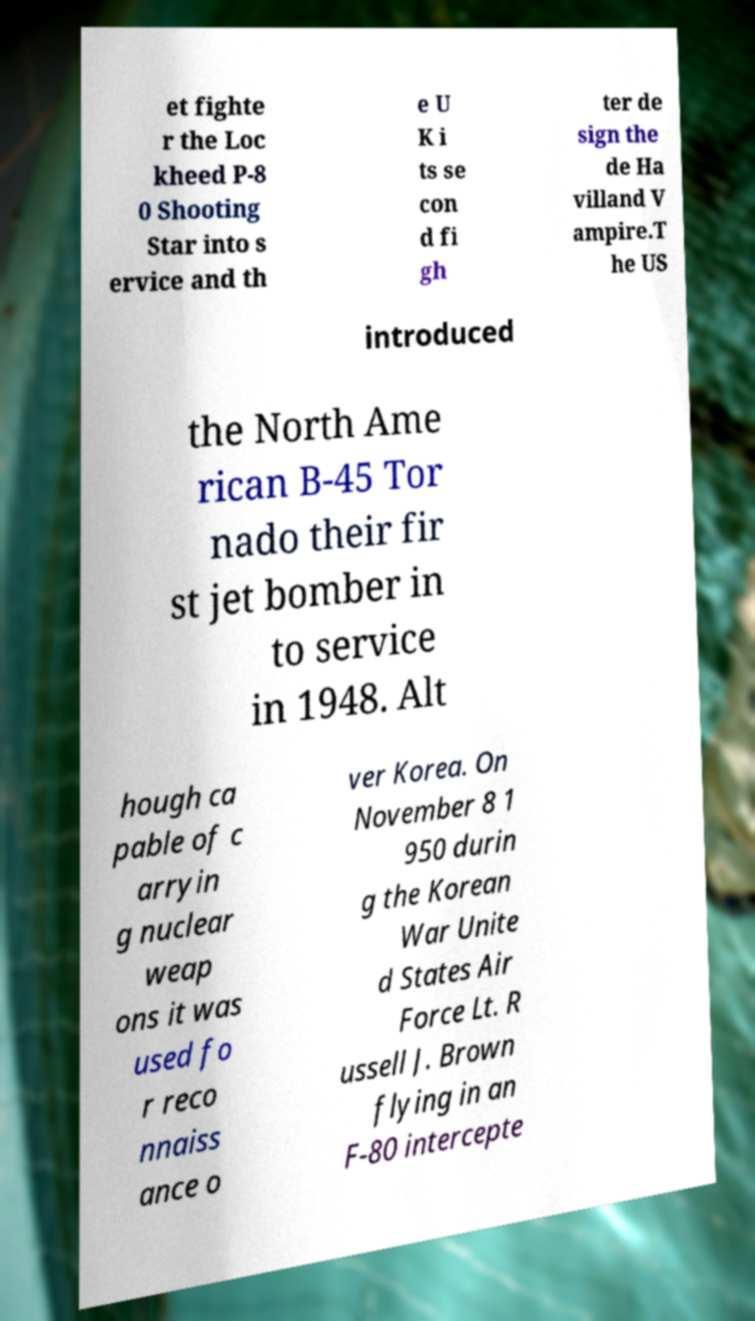Please identify and transcribe the text found in this image. et fighte r the Loc kheed P-8 0 Shooting Star into s ervice and th e U K i ts se con d fi gh ter de sign the de Ha villand V ampire.T he US introduced the North Ame rican B-45 Tor nado their fir st jet bomber in to service in 1948. Alt hough ca pable of c arryin g nuclear weap ons it was used fo r reco nnaiss ance o ver Korea. On November 8 1 950 durin g the Korean War Unite d States Air Force Lt. R ussell J. Brown flying in an F-80 intercepte 